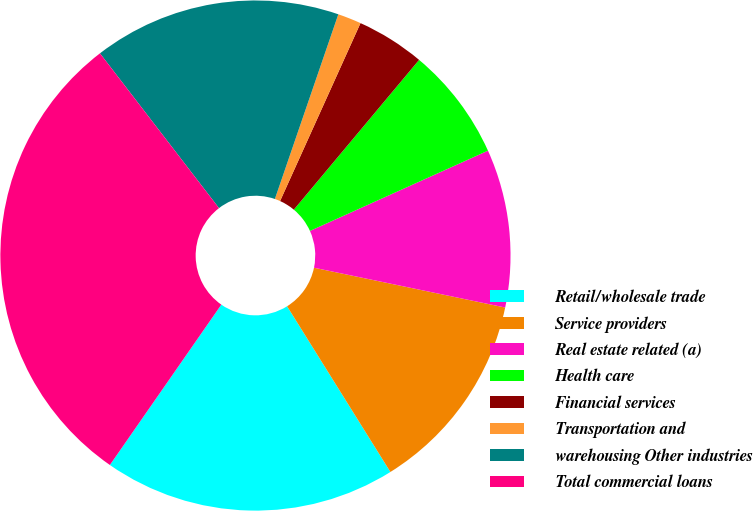<chart> <loc_0><loc_0><loc_500><loc_500><pie_chart><fcel>Retail/wholesale trade<fcel>Service providers<fcel>Real estate related (a)<fcel>Health care<fcel>Financial services<fcel>Transportation and<fcel>warehousing Other industries<fcel>Total commercial loans<nl><fcel>18.54%<fcel>12.86%<fcel>10.01%<fcel>7.17%<fcel>4.33%<fcel>1.49%<fcel>15.7%<fcel>29.9%<nl></chart> 